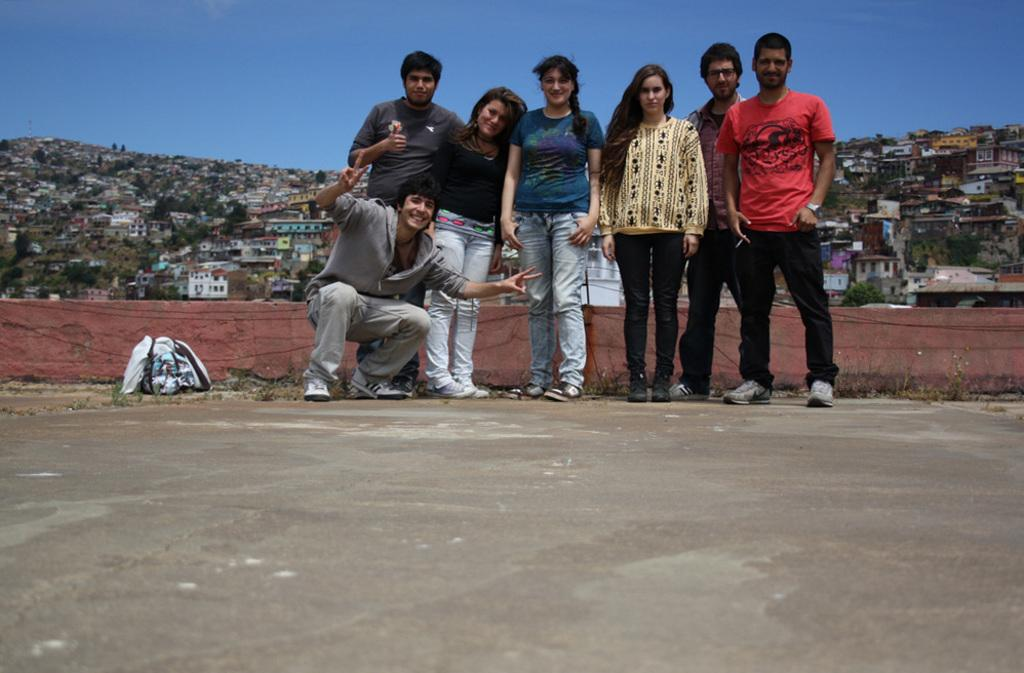What is happening in the center of the image? There is a group of persons standing in the center of the image. Where are the persons standing? The group of persons is standing on the floor. What can be seen in the background of the image? There are many buildings, a hill, fencing, and the sky visible in the background of the image. What type of horn is being played by the squirrel in the image? There is no squirrel or horn present in the image. How is the string attached to the persons in the image? There is no string attached to the persons in the image. 